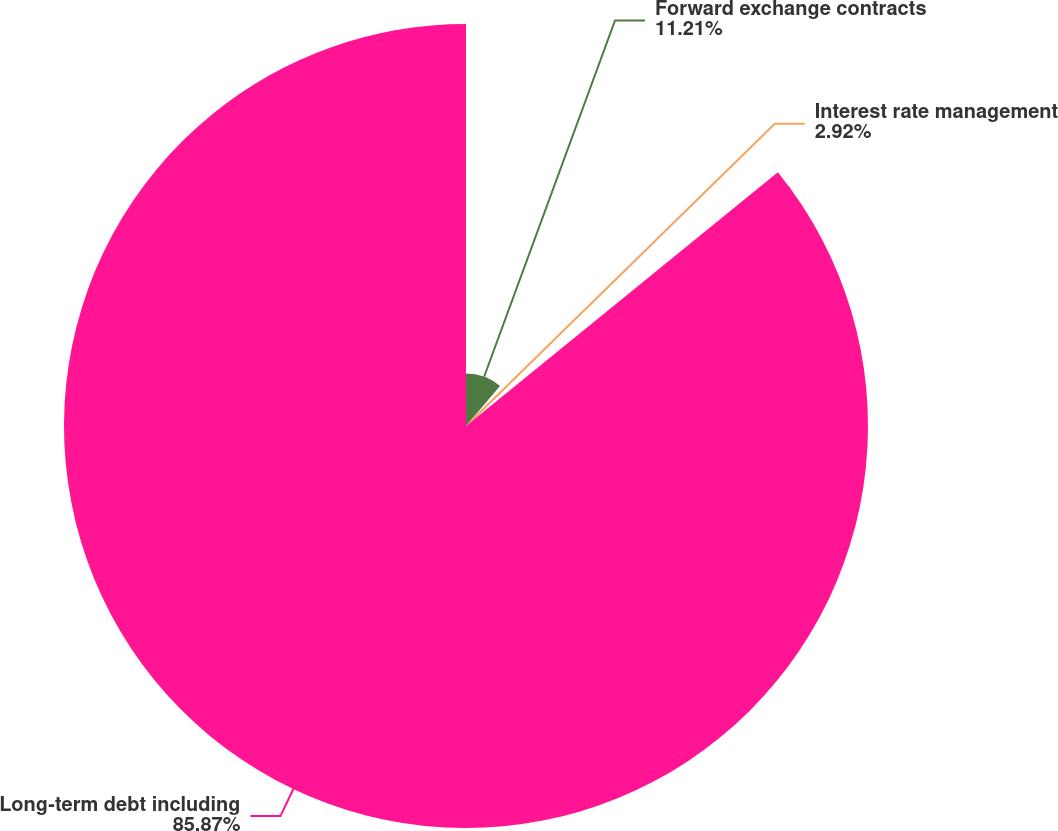Convert chart to OTSL. <chart><loc_0><loc_0><loc_500><loc_500><pie_chart><fcel>Forward exchange contracts<fcel>Interest rate management<fcel>Long-term debt including<nl><fcel>11.21%<fcel>2.92%<fcel>85.86%<nl></chart> 